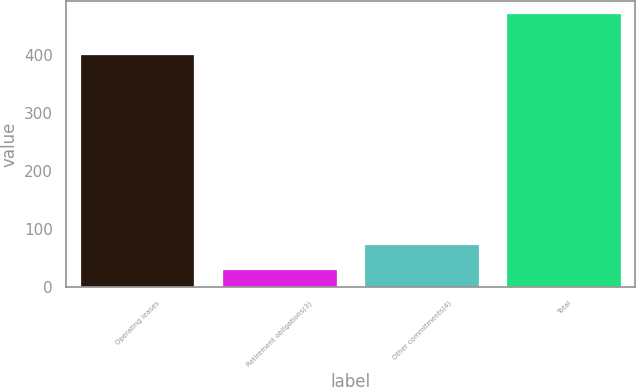Convert chart. <chart><loc_0><loc_0><loc_500><loc_500><bar_chart><fcel>Operating leases<fcel>Retirement obligations(3)<fcel>Other commitments(4)<fcel>Total<nl><fcel>400<fcel>29<fcel>73.1<fcel>470<nl></chart> 